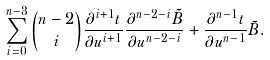<formula> <loc_0><loc_0><loc_500><loc_500>\sum _ { i = 0 } ^ { n - 3 } \binom { n - 2 } { i } \frac { \partial ^ { i + 1 } t } { \partial u ^ { i + 1 } } \frac { \partial ^ { n - 2 - i } \tilde { B } } { \partial u ^ { n - 2 - i } } + \frac { \partial ^ { n - 1 } t } { \partial u ^ { n - 1 } } \tilde { B } .</formula> 